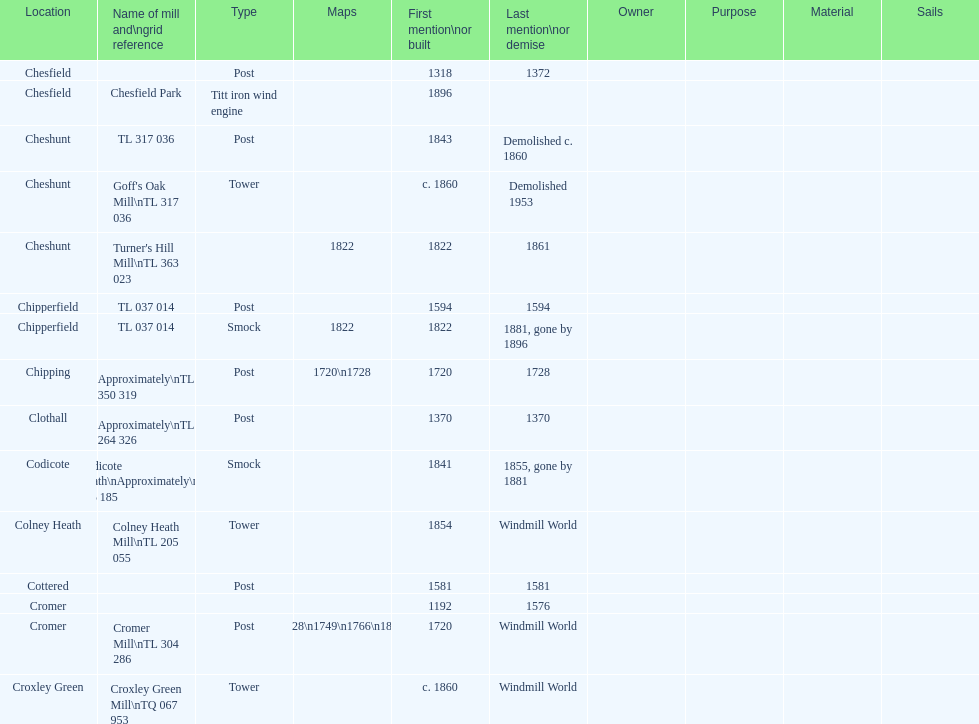How man "c" windmills have there been? 15. 